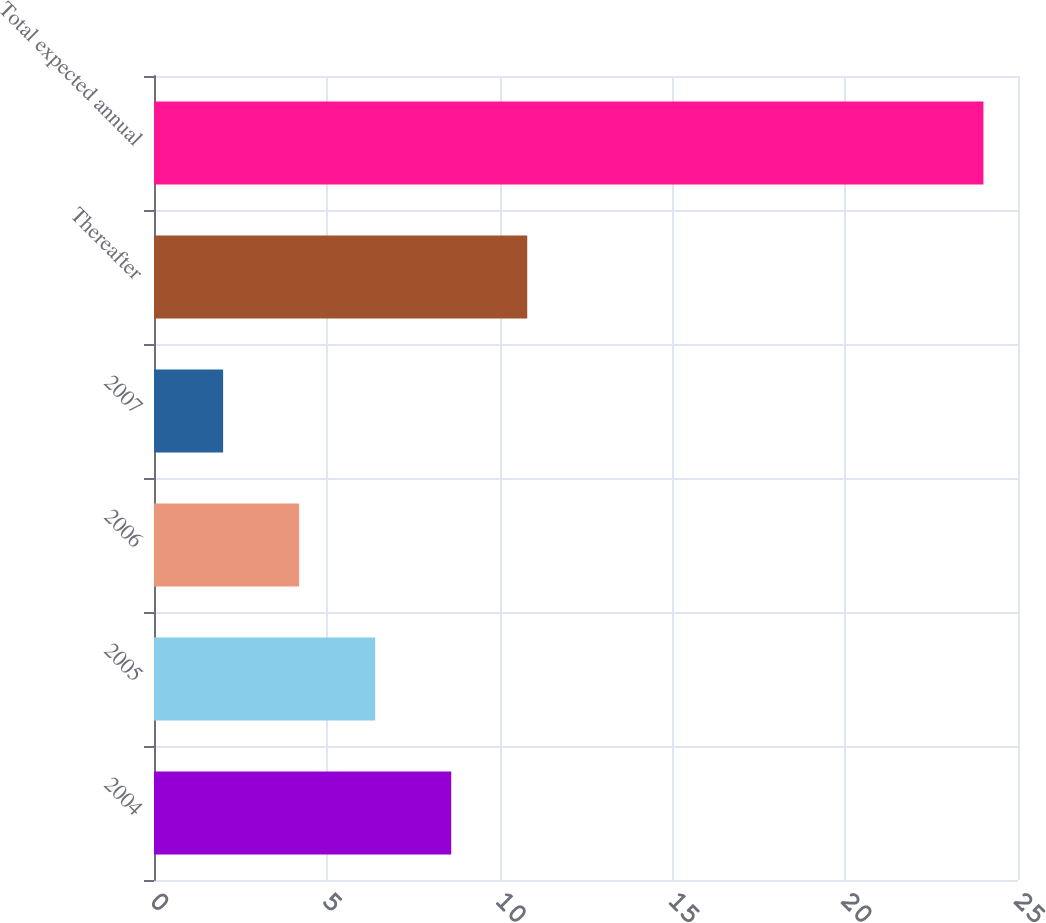Convert chart. <chart><loc_0><loc_0><loc_500><loc_500><bar_chart><fcel>2004<fcel>2005<fcel>2006<fcel>2007<fcel>Thereafter<fcel>Total expected annual<nl><fcel>8.6<fcel>6.4<fcel>4.2<fcel>2<fcel>10.8<fcel>24<nl></chart> 